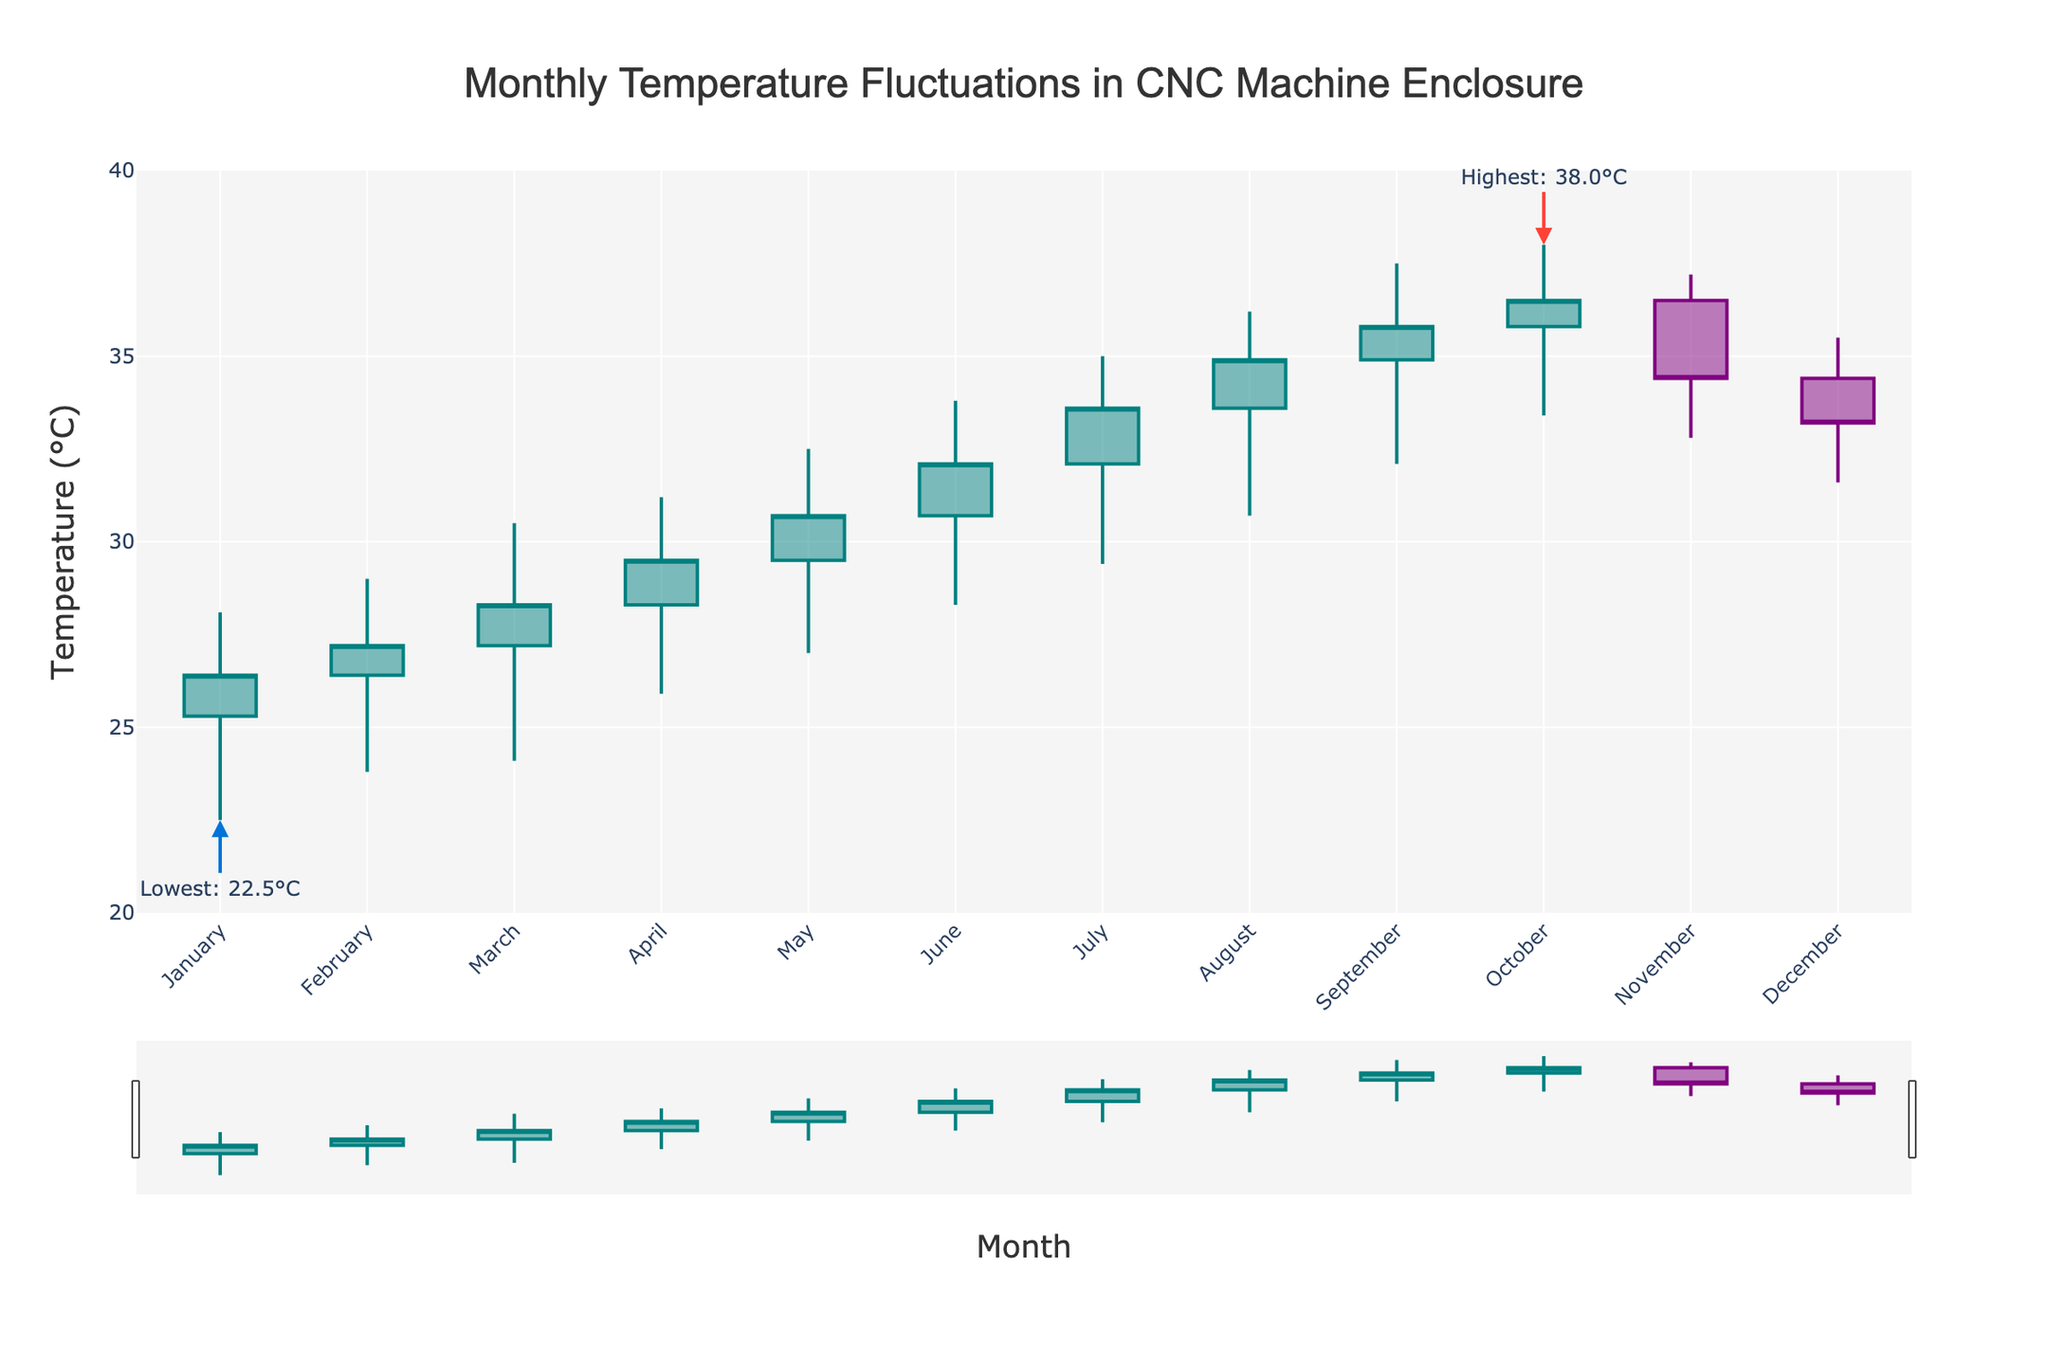What is the title of the figure? The title of the figure is displayed at the top center and reads: "Monthly Temperature Fluctuations in CNC Machine Enclosure".
Answer: Monthly Temperature Fluctuations in CNC Machine Enclosure Which month has the highest recorded temperature? By looking at the 'High' values, the highest temperature recorded is 38.0°C, which occurs in October. This is noted by the annotation near the top of the plot.
Answer: October Which month experienced the lowest temperature and what was that temperature? Looking at the 'Low' values, the lowest temperature recorded is 22.5°C in January. This is also highlighted in the figure with an annotation.
Answer: January, 22.5°C What are the colors used to represent increasing and decreasing temperatures? The plot uses teal color for increasing temperatures and purple color for decreasing temperatures in the candlestick plot.
Answer: Teal for increasing, Purple for decreasing What is the range of temperatures recorded in the year? The lowest temperature recorded is 22.5°C and the highest is 38.0°C. Therefore, the temperature range is from 22.5°C to 38.0°C.
Answer: 22.5°C to 38.0°C Between which two consecutive months is the largest increase in closing temperatures observed? By comparing the closing temperatures, the largest increase is between December (33.2°C) and January (26.4°C), which gives an increase of 7.2°C.
Answer: December to January What is the average high temperature for the months of June, July, and August? Add the high temperatures for June (33.8°C), July (35.0°C), and August (36.2°C) and then divide by 3: (33.8 + 35.0 + 36.2)/3 = 35.0°C.
Answer: 35.0°C Does the close temperature for November exceed the opening temperature for the next month (December)? The close temperature for November is 34.4°C, and the opening temperature for December is 34.4°C. These values are equal, so the close temperature does not exceed the opening temperature.
Answer: No Which month shows the least fluctuation in temperature (difference between high and low temperatures)? Calculate the difference between the high and low temperatures for each month and find the smallest difference. For November, the difference is (37.2 - 32.8) = 4.4°C, which is the smallest fluctuation.
Answer: November What is the median closing temperature of the year? List all closing temperatures: [26.4, 27.2, 28.3, 29.5, 30.7, 32.1, 33.6, 34.9, 35.8, 36.5, 34.4, 33.2]. The middle values are 32.1 and 33.2. The median is the average of these two: (32.1 + 33.2) / 2 = 32.65°C.
Answer: 32.65°C 